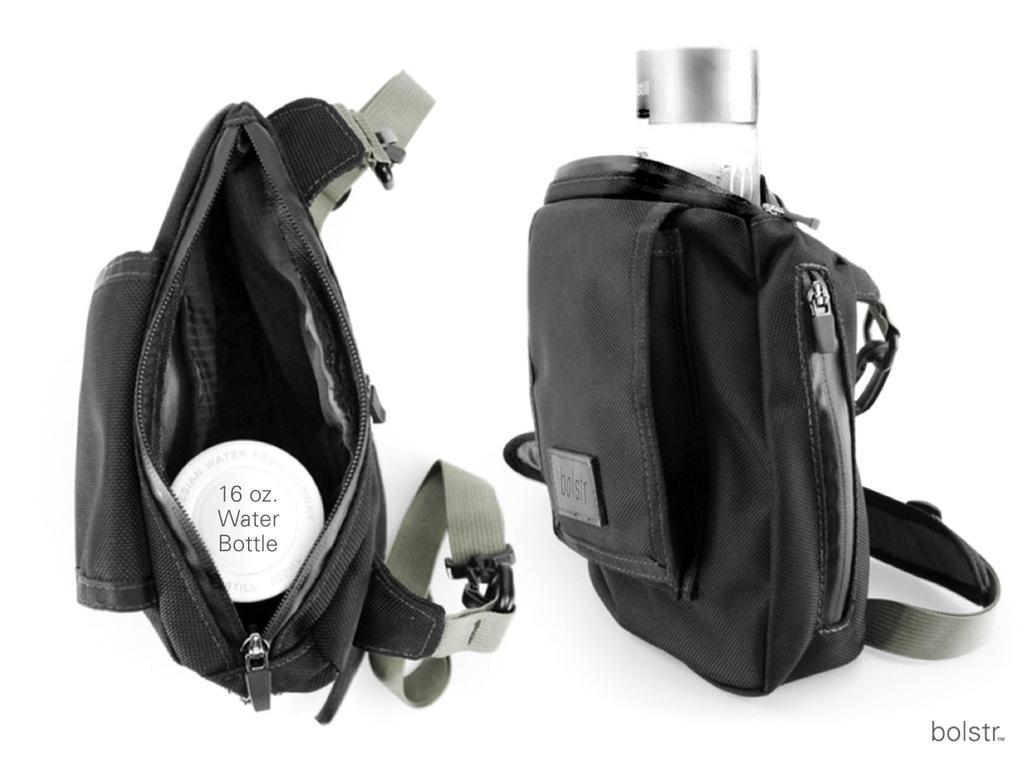Can you describe this image briefly? There are two bags with water bottles in it. 